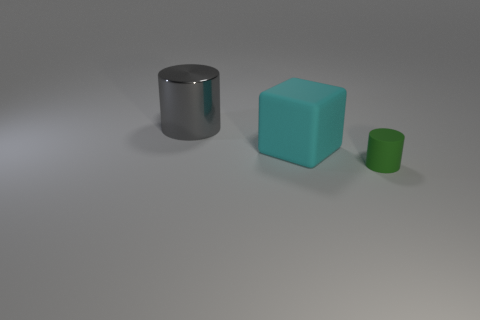There is a large gray metallic object; is it the same shape as the matte thing behind the green object?
Give a very brief answer. No. Are there fewer large gray metallic cylinders that are in front of the small green rubber cylinder than cyan matte things?
Your response must be concise. Yes. Is the gray metallic thing the same shape as the tiny matte thing?
Your response must be concise. Yes. There is a green object that is made of the same material as the block; what size is it?
Your response must be concise. Small. Are there fewer big cyan things than red shiny objects?
Offer a terse response. No. What number of small objects are cyan matte cubes or metal things?
Offer a very short reply. 0. What number of things are both behind the green cylinder and right of the metallic object?
Your answer should be very brief. 1. Is the number of small green objects greater than the number of cylinders?
Ensure brevity in your answer.  No. How many other things are there of the same shape as the big cyan rubber thing?
Offer a very short reply. 0. Does the metallic thing have the same color as the tiny rubber thing?
Offer a very short reply. No. 